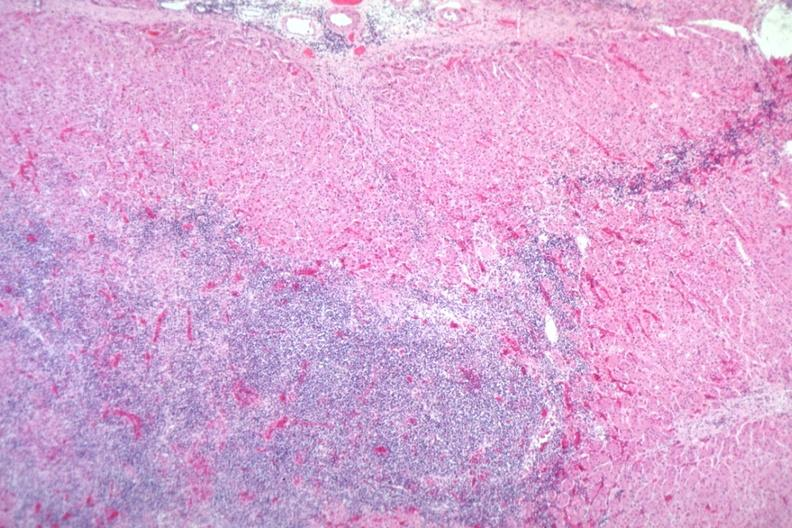does aldehyde fuscin show easily seen infiltrate?
Answer the question using a single word or phrase. No 